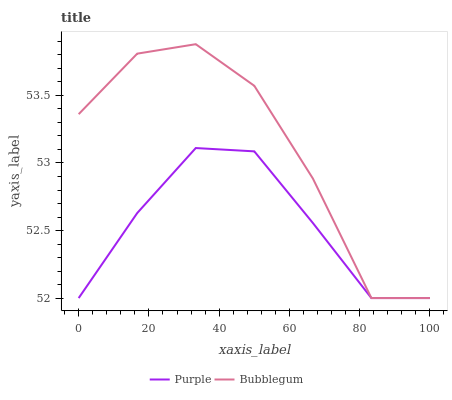Does Purple have the minimum area under the curve?
Answer yes or no. Yes. Does Bubblegum have the maximum area under the curve?
Answer yes or no. Yes. Does Bubblegum have the minimum area under the curve?
Answer yes or no. No. Is Purple the smoothest?
Answer yes or no. Yes. Is Bubblegum the roughest?
Answer yes or no. Yes. Is Bubblegum the smoothest?
Answer yes or no. No. Does Purple have the lowest value?
Answer yes or no. Yes. Does Bubblegum have the highest value?
Answer yes or no. Yes. Does Bubblegum intersect Purple?
Answer yes or no. Yes. Is Bubblegum less than Purple?
Answer yes or no. No. Is Bubblegum greater than Purple?
Answer yes or no. No. 